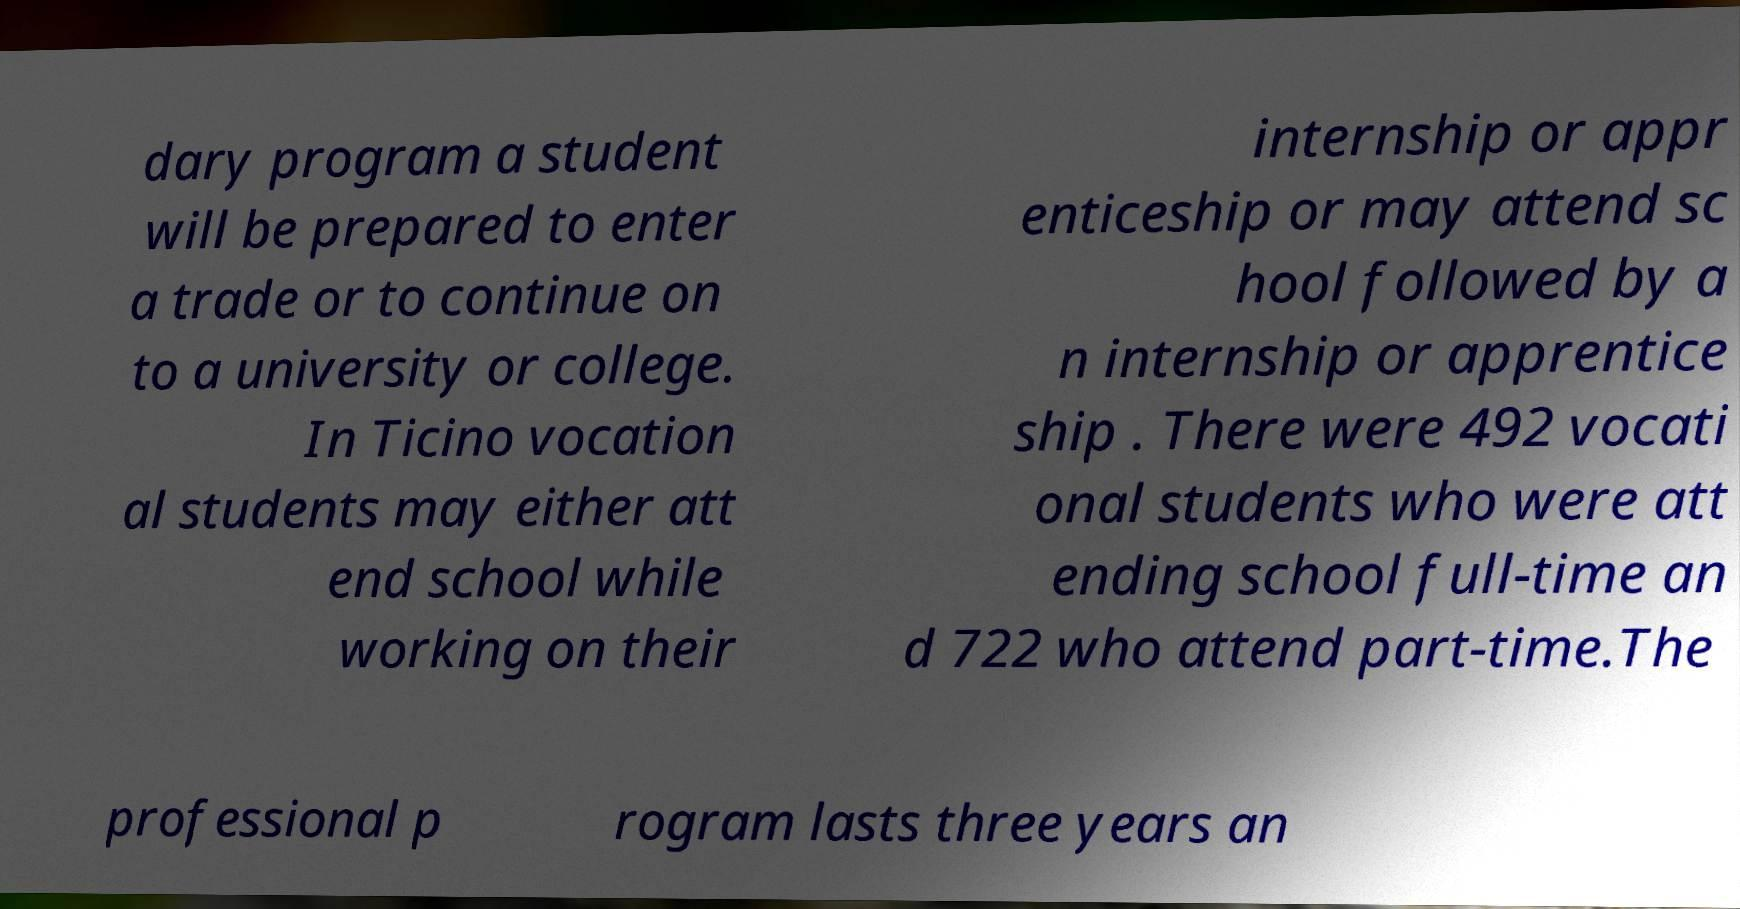Could you extract and type out the text from this image? dary program a student will be prepared to enter a trade or to continue on to a university or college. In Ticino vocation al students may either att end school while working on their internship or appr enticeship or may attend sc hool followed by a n internship or apprentice ship . There were 492 vocati onal students who were att ending school full-time an d 722 who attend part-time.The professional p rogram lasts three years an 